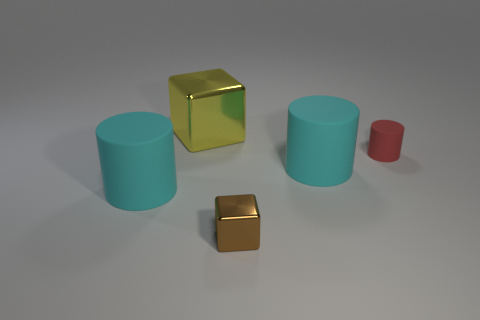Add 1 red rubber balls. How many objects exist? 6 Subtract all cylinders. How many objects are left? 2 Add 4 matte cylinders. How many matte cylinders exist? 7 Subtract 0 blue spheres. How many objects are left? 5 Subtract all large yellow blocks. Subtract all big purple spheres. How many objects are left? 4 Add 2 large yellow metallic things. How many large yellow metallic things are left? 3 